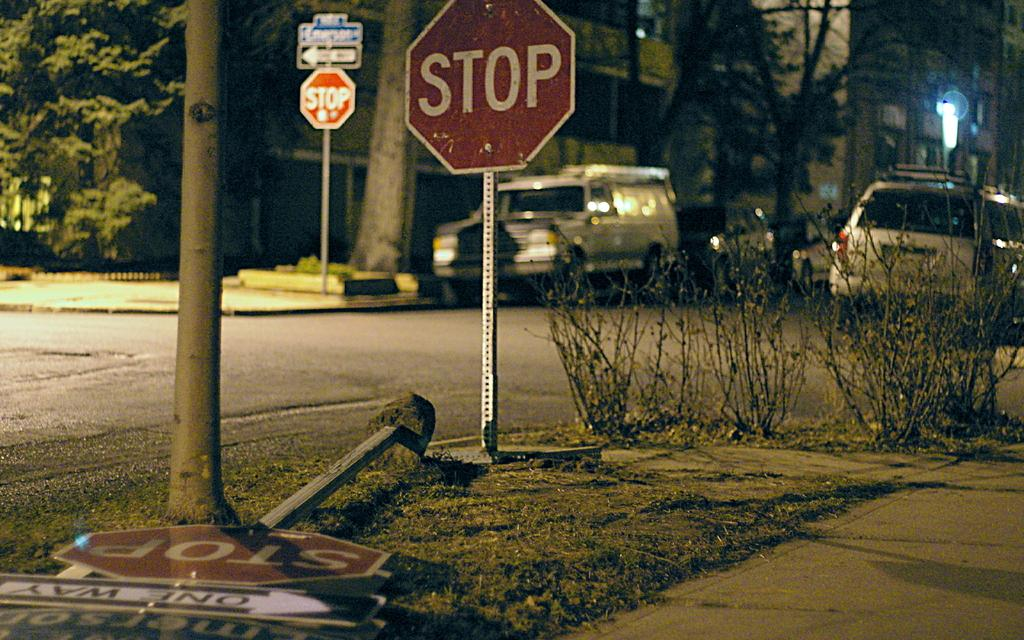<image>
Render a clear and concise summary of the photo. A new stop sign stands next to a knocked over one with a One Way sign attached to it. 